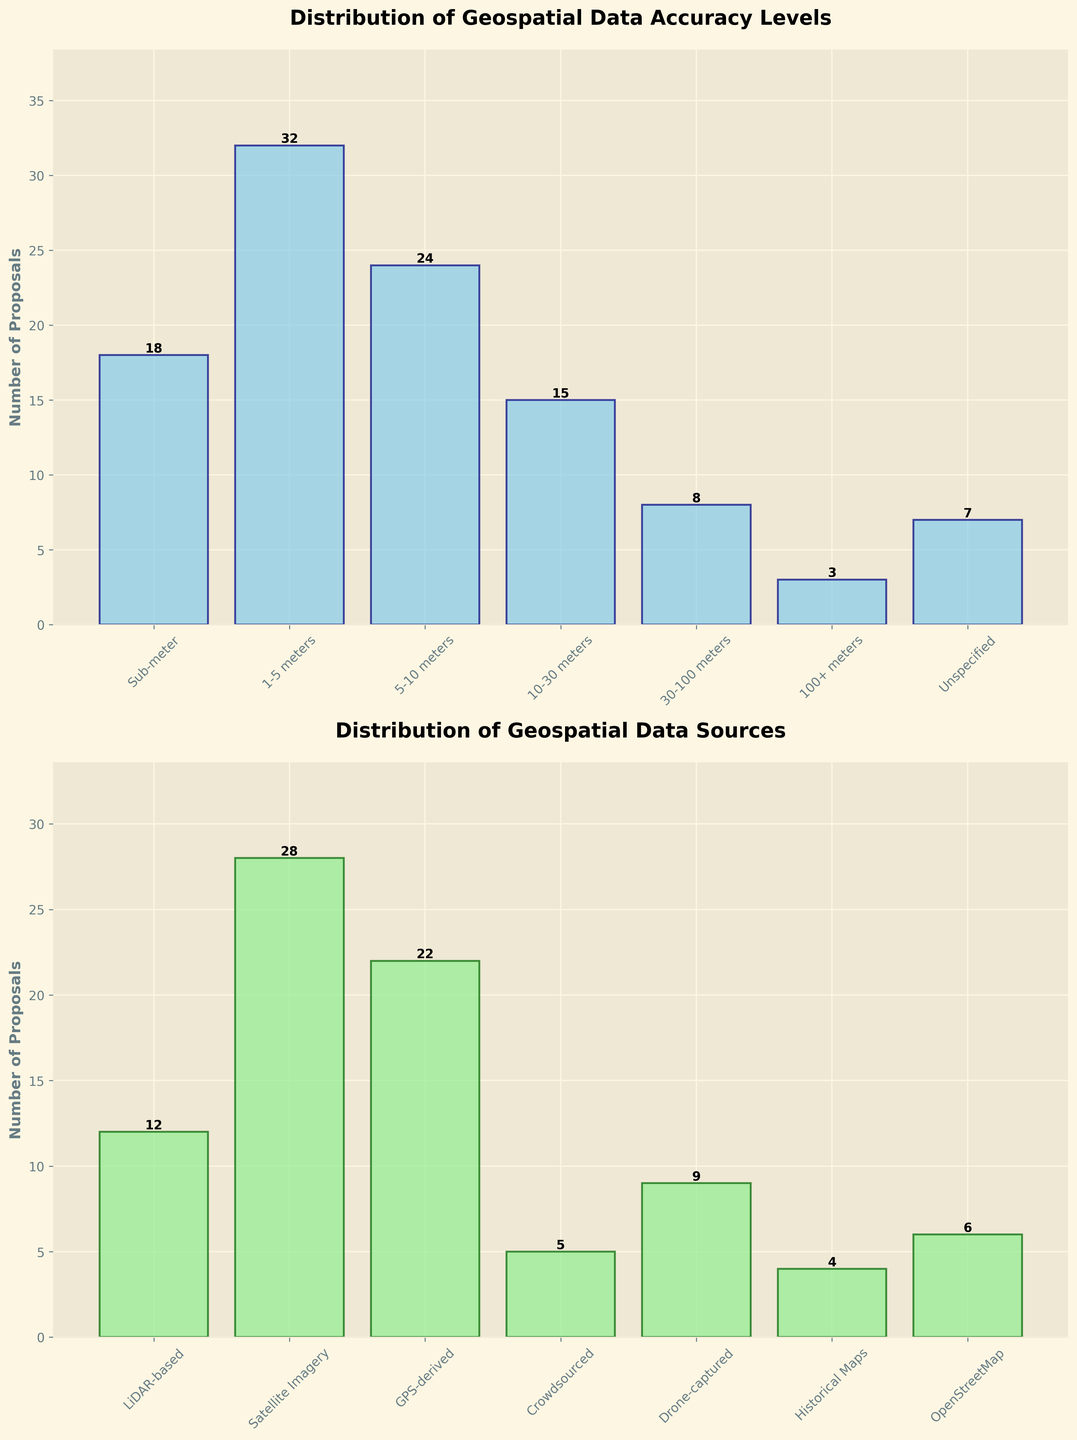What is the total number of proposals that have specified an accuracy level? Sum the number of proposals under each specified accuracy level category (Sub-meter, 1-5 meters, 5-10 meters, 10-30 meters, 30-100 meters, 100+ meters)
Answer: 100 Which accuracy level category has the highest number of proposals? Identify the category with the highest bar under 'Distribution of Geospatial Data Accuracy Levels'
Answer: 1-5 meters Does Satellite Imagery have more proposals than GPS-derived data? Compare the height of the bars representing Satellite Imagery and GPS-derived data under 'Distribution of Geospatial Data Sources'
Answer: Yes What is the difference in the number of proposals between Sub-meter and Unspecified accuracy levels? Subtract the number of proposals for Unspecified accuracy level from that for Sub-meter accuracy level
Answer: 11 What is the combined number of proposals using LiDAR-based and Drone-captured data sources? Add the number of proposals for LiDAR-based and Drone-captured data sources
Answer: 21 Does the category OpenStreetMap have a higher or lower number of proposals than Historical Maps? Compare the heights of the bars representing OpenStreetMap and Historical Maps under 'Distribution of Geospatial Data Sources'
Answer: Higher What is the average number of proposals for all accuracy levels? Sum the number of proposals for all accuracy levels and then divide by the number of accuracy levels (7 categories)
Answer: 15 Which category has a lower number of proposals, Crowdsourced data sources or 100+ meters accuracy level? Compare the heights of the bars representing Crowdsourced data sources and 100+ meters accuracy level
Answer: 100+ meters What's the sum of the number of proposals for the top two highest proposal categories under accuracy levels? Identify the top two accuracy levels with the highest number of proposals, then sum their proposals
Answer: 50 (32 + 18) 